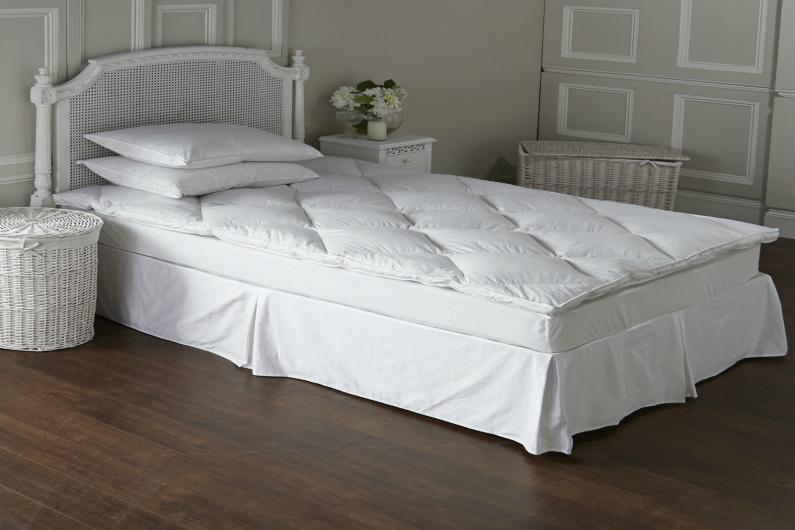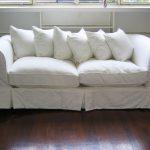The first image is the image on the left, the second image is the image on the right. Given the left and right images, does the statement "The left and right image contains the same number of bed." hold true? Answer yes or no. No. The first image is the image on the left, the second image is the image on the right. Examine the images to the left and right. Is the description "Each image shows a bed with non-white pillows on top and a dark head- and foot-board, displayed at an angle." accurate? Answer yes or no. No. 